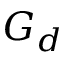<formula> <loc_0><loc_0><loc_500><loc_500>G _ { d }</formula> 